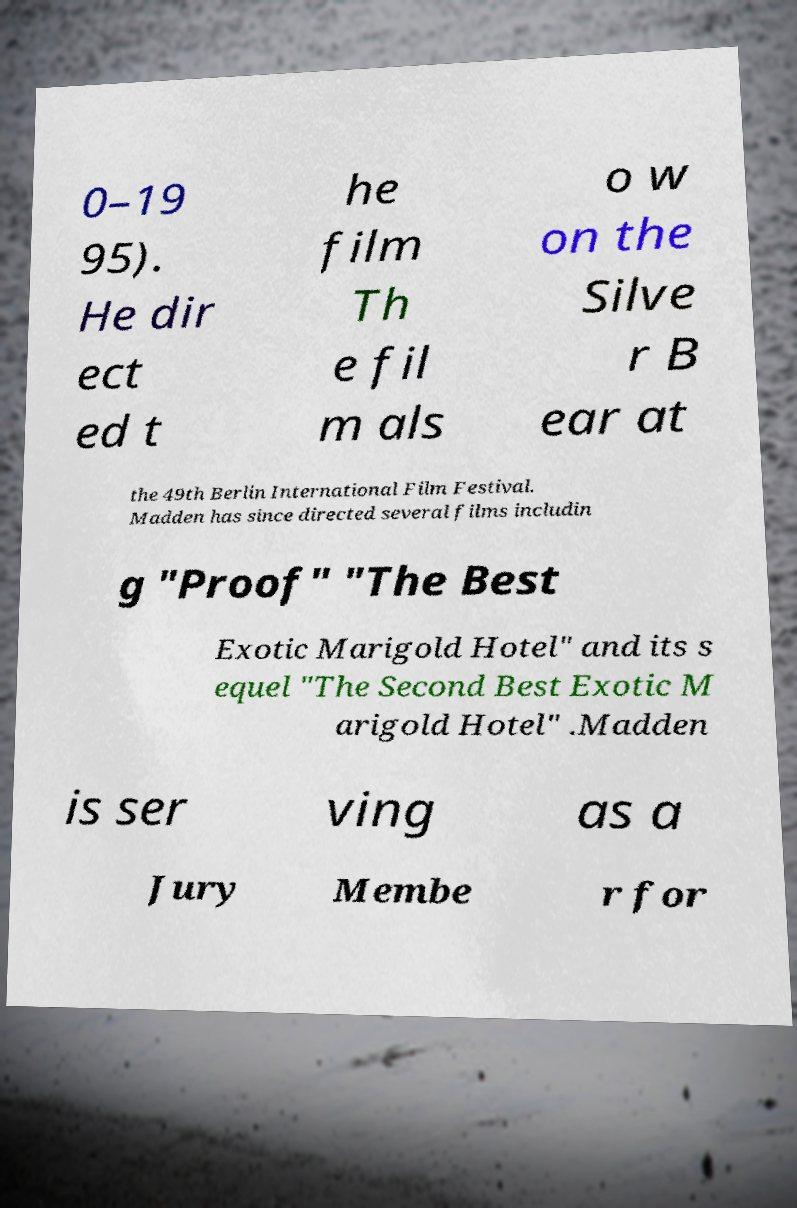Please identify and transcribe the text found in this image. 0–19 95). He dir ect ed t he film Th e fil m als o w on the Silve r B ear at the 49th Berlin International Film Festival. Madden has since directed several films includin g "Proof" "The Best Exotic Marigold Hotel" and its s equel "The Second Best Exotic M arigold Hotel" .Madden is ser ving as a Jury Membe r for 